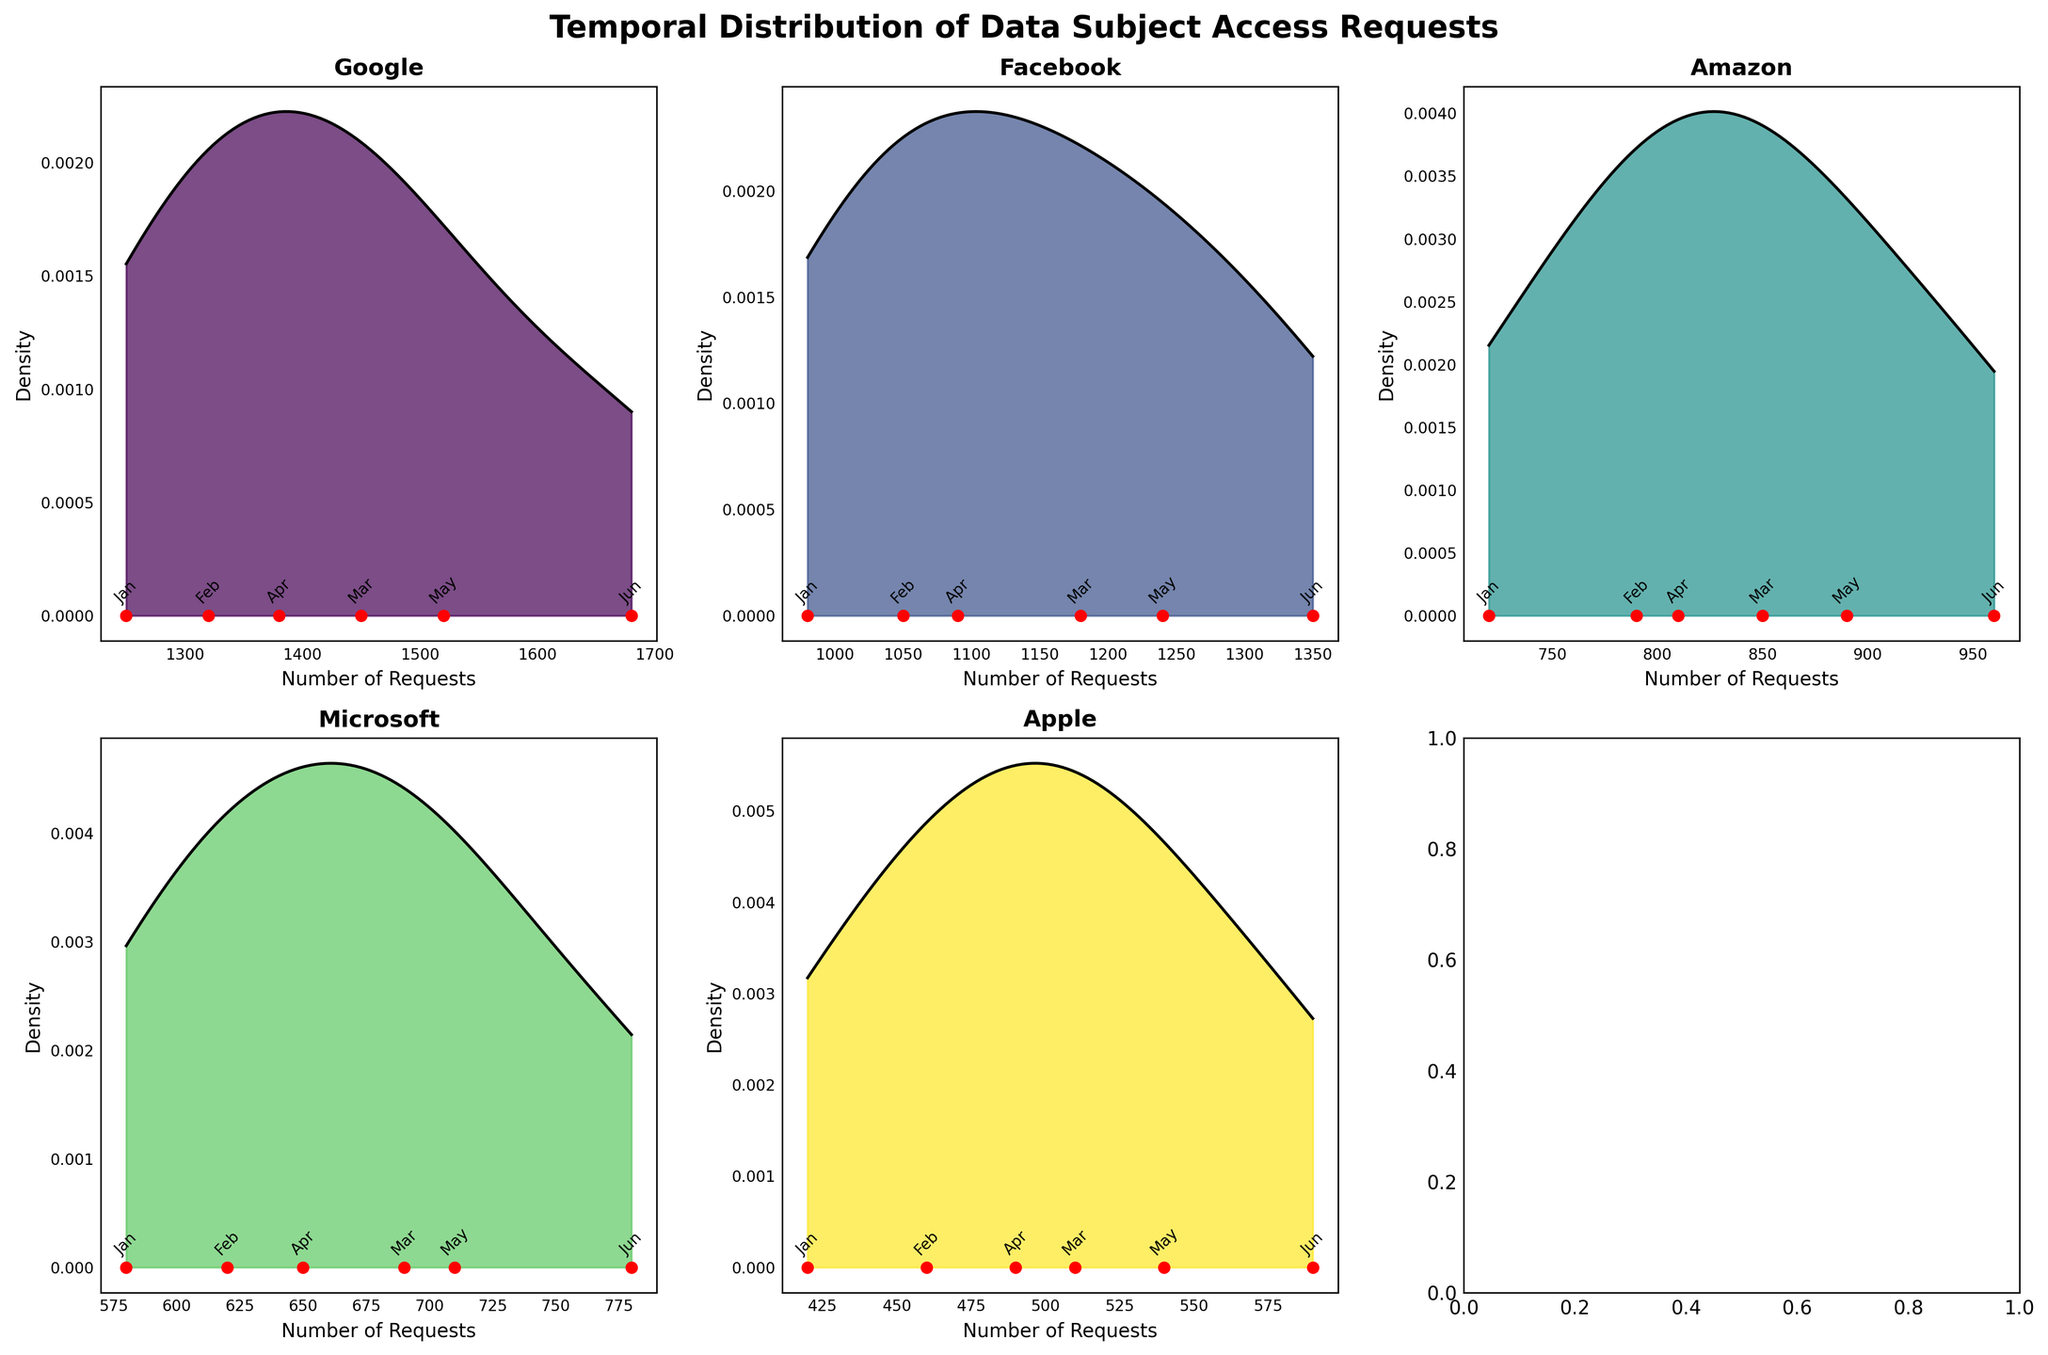What is the title of the figure? The title of the figure is displayed at the top center in bold. To determine the title, you simply need to look at this area and read the text.
Answer: Temporal Distribution of Data Subject Access Requests Which organization received the highest number of requests in March? To find which organization received the highest number of requests in March, you need to compare the March data points in each subplot. The organization with the highest density peak for March gives the answer.
Answer: Google How many months are represented in each subplot? Look at each subplot and count the number of labeled data points along the x-axis. Each subplot has the data points for the same six months.
Answer: 6 Which organization's data has the widest range of request numbers? Identify the organization by examining the x-axis range of each subplot, which represents the number of requests. The subplot with the widest range shows the x-axis span.
Answer: Google Which organization has the lowest density peak for May? Check the density curves for each subplot and identify the peak values for the month of May. By comparing them, determine which is the lowest.
Answer: Apple Which organization has the most consistent (least varying) number of requests over the months? Compare the density plots' spreads. The organization with the narrowest density peak indicates the least variability in request numbers.
Answer: Apple What is the approximate peak density value for Facebook in June? Identify the density curve for Facebook and look at the peak corresponding to June. Estimate the highest point on this curve by following the y-axis.
Answer: Around ~0.0025 For which months does Amazon have the lowest request numbers? Look along Amazon's subplot and identify the months by the position of the data points on the x-axis, then compare them to determine the lowest numbers.
Answer: January Which organization shows an increasing trend in the number of requests from January to June? By reviewing the data points' distribution for each organization consistently going higher, identify which one's density curve follows an upward trend from January to June.
Answer: Google Are there any organizations with a bimodal distribution of requests over the months? Examine each density plot for two peaks. If an organization’s density curve has two distinct peaks, it indicates a bimodal distribution of requests.
Answer: No 